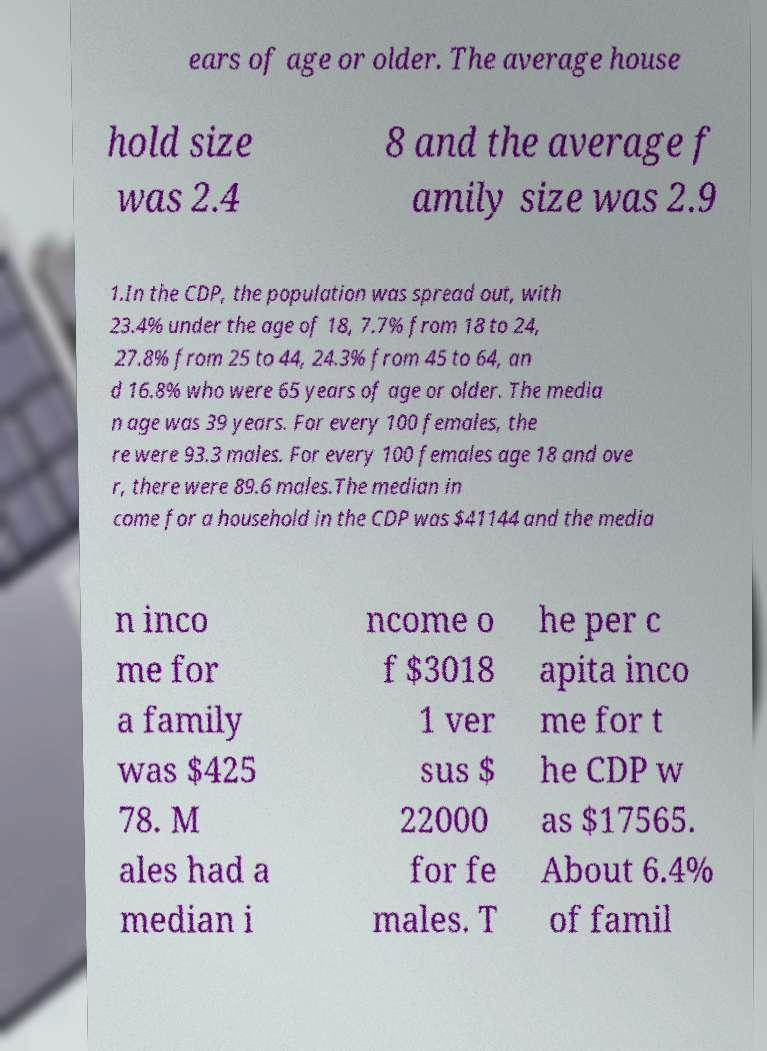Please identify and transcribe the text found in this image. ears of age or older. The average house hold size was 2.4 8 and the average f amily size was 2.9 1.In the CDP, the population was spread out, with 23.4% under the age of 18, 7.7% from 18 to 24, 27.8% from 25 to 44, 24.3% from 45 to 64, an d 16.8% who were 65 years of age or older. The media n age was 39 years. For every 100 females, the re were 93.3 males. For every 100 females age 18 and ove r, there were 89.6 males.The median in come for a household in the CDP was $41144 and the media n inco me for a family was $425 78. M ales had a median i ncome o f $3018 1 ver sus $ 22000 for fe males. T he per c apita inco me for t he CDP w as $17565. About 6.4% of famil 